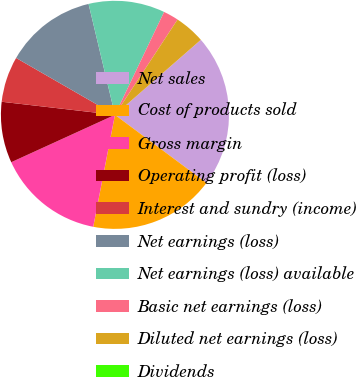Convert chart to OTSL. <chart><loc_0><loc_0><loc_500><loc_500><pie_chart><fcel>Net sales<fcel>Cost of products sold<fcel>Gross margin<fcel>Operating profit (loss)<fcel>Interest and sundry (income)<fcel>Net earnings (loss)<fcel>Net earnings (loss) available<fcel>Basic net earnings (loss)<fcel>Diluted net earnings (loss)<fcel>Dividends<nl><fcel>21.61%<fcel>17.87%<fcel>15.13%<fcel>8.65%<fcel>6.48%<fcel>12.97%<fcel>10.81%<fcel>2.16%<fcel>4.32%<fcel>0.0%<nl></chart> 